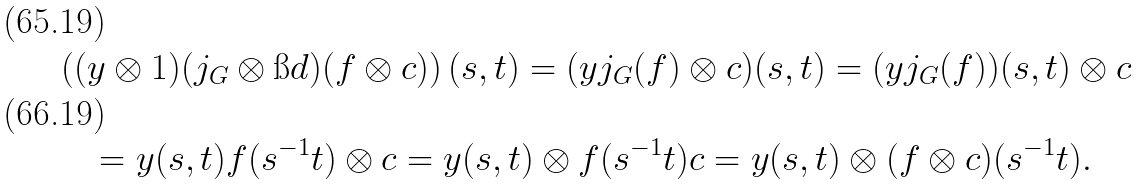<formula> <loc_0><loc_0><loc_500><loc_500>& \left ( ( y \otimes 1 ) ( j _ { G } \otimes \i d ) ( f \otimes c ) \right ) ( s , t ) = ( y j _ { G } ( f ) \otimes c ) ( s , t ) = ( y j _ { G } ( f ) ) ( s , t ) \otimes c \\ & \quad = y ( s , t ) f ( s ^ { - 1 } t ) \otimes c = y ( s , t ) \otimes f ( s ^ { - 1 } t ) c = y ( s , t ) \otimes ( f \otimes c ) ( s ^ { - 1 } t ) .</formula> 